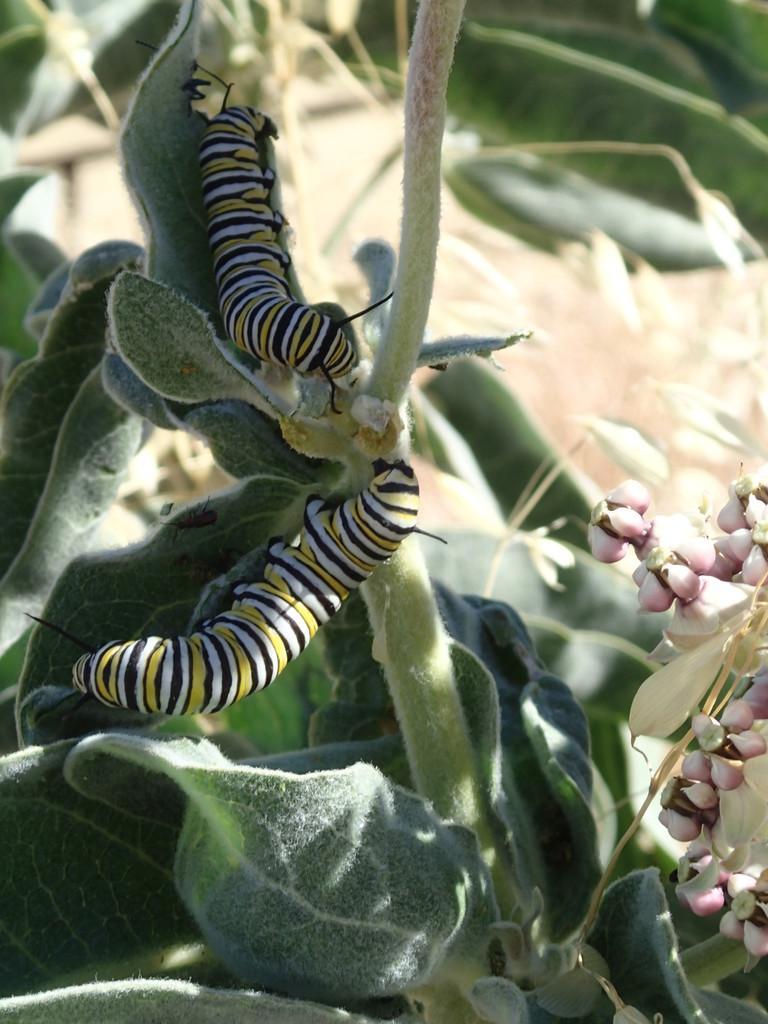Describe this image in one or two sentences. Here we can see insects, bugs, and plants. 